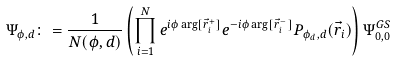<formula> <loc_0><loc_0><loc_500><loc_500>\Psi _ { \phi , d } \colon = \frac { 1 } { N ( \phi , d ) } \left ( \prod _ { i = 1 } ^ { N } e ^ { i \phi \arg [ \vec { r } _ { i } ^ { + } ] } e ^ { - i \phi \arg [ \vec { r } _ { i } ^ { - } ] } P _ { \phi _ { d } , d } ( \vec { r } _ { i } ) \right ) \Psi ^ { G S } _ { 0 , 0 }</formula> 